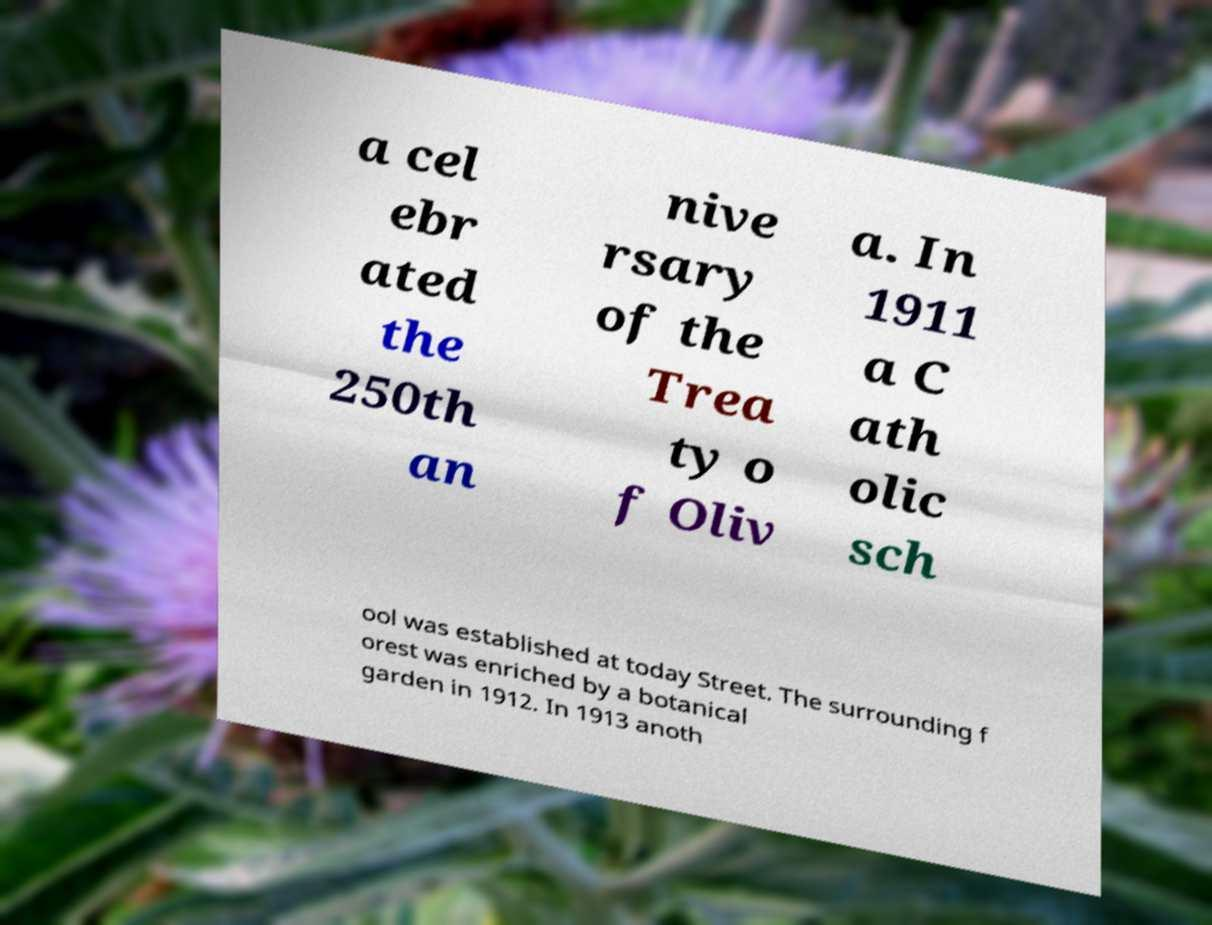Could you assist in decoding the text presented in this image and type it out clearly? a cel ebr ated the 250th an nive rsary of the Trea ty o f Oliv a. In 1911 a C ath olic sch ool was established at today Street. The surrounding f orest was enriched by a botanical garden in 1912. In 1913 anoth 